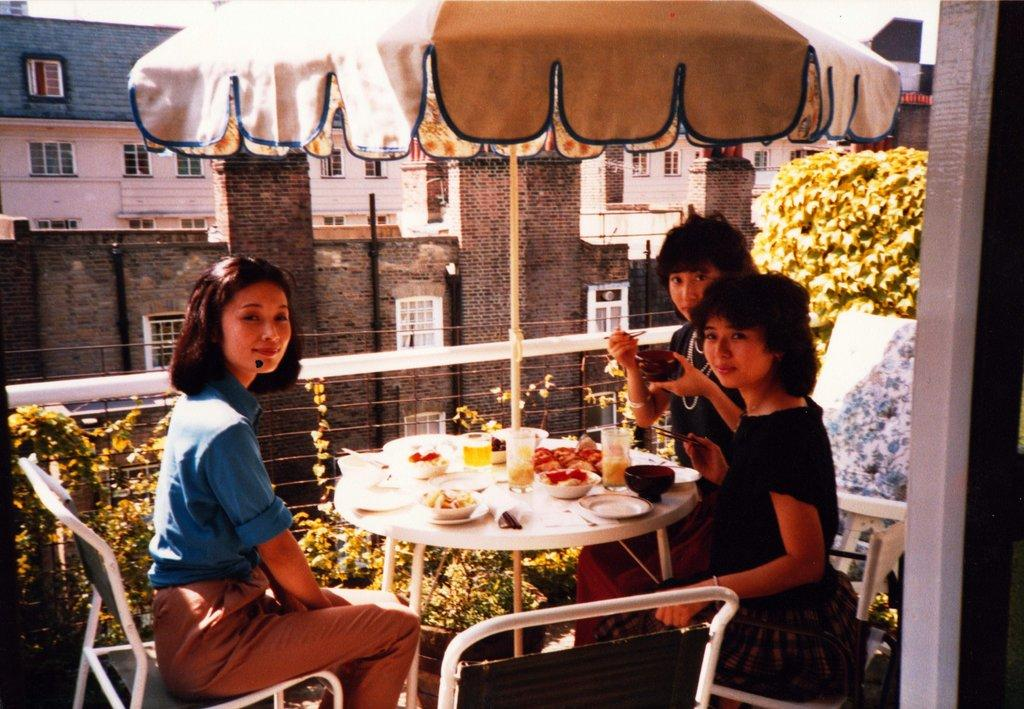How many people are in the picture? There are three people in the picture. What are the people doing in the image? The people are sitting on chairs. How are the chairs arranged in the image? The chairs are arranged around a table. What can be seen on the table in the image? There are food items on the table. What can be seen in the background of the image? There are plants visible in the background. What type of bean is being used to increase profit in the image? There is no mention of beans or profit in the image; it features three people sitting around a table with food items and plants in the background. 